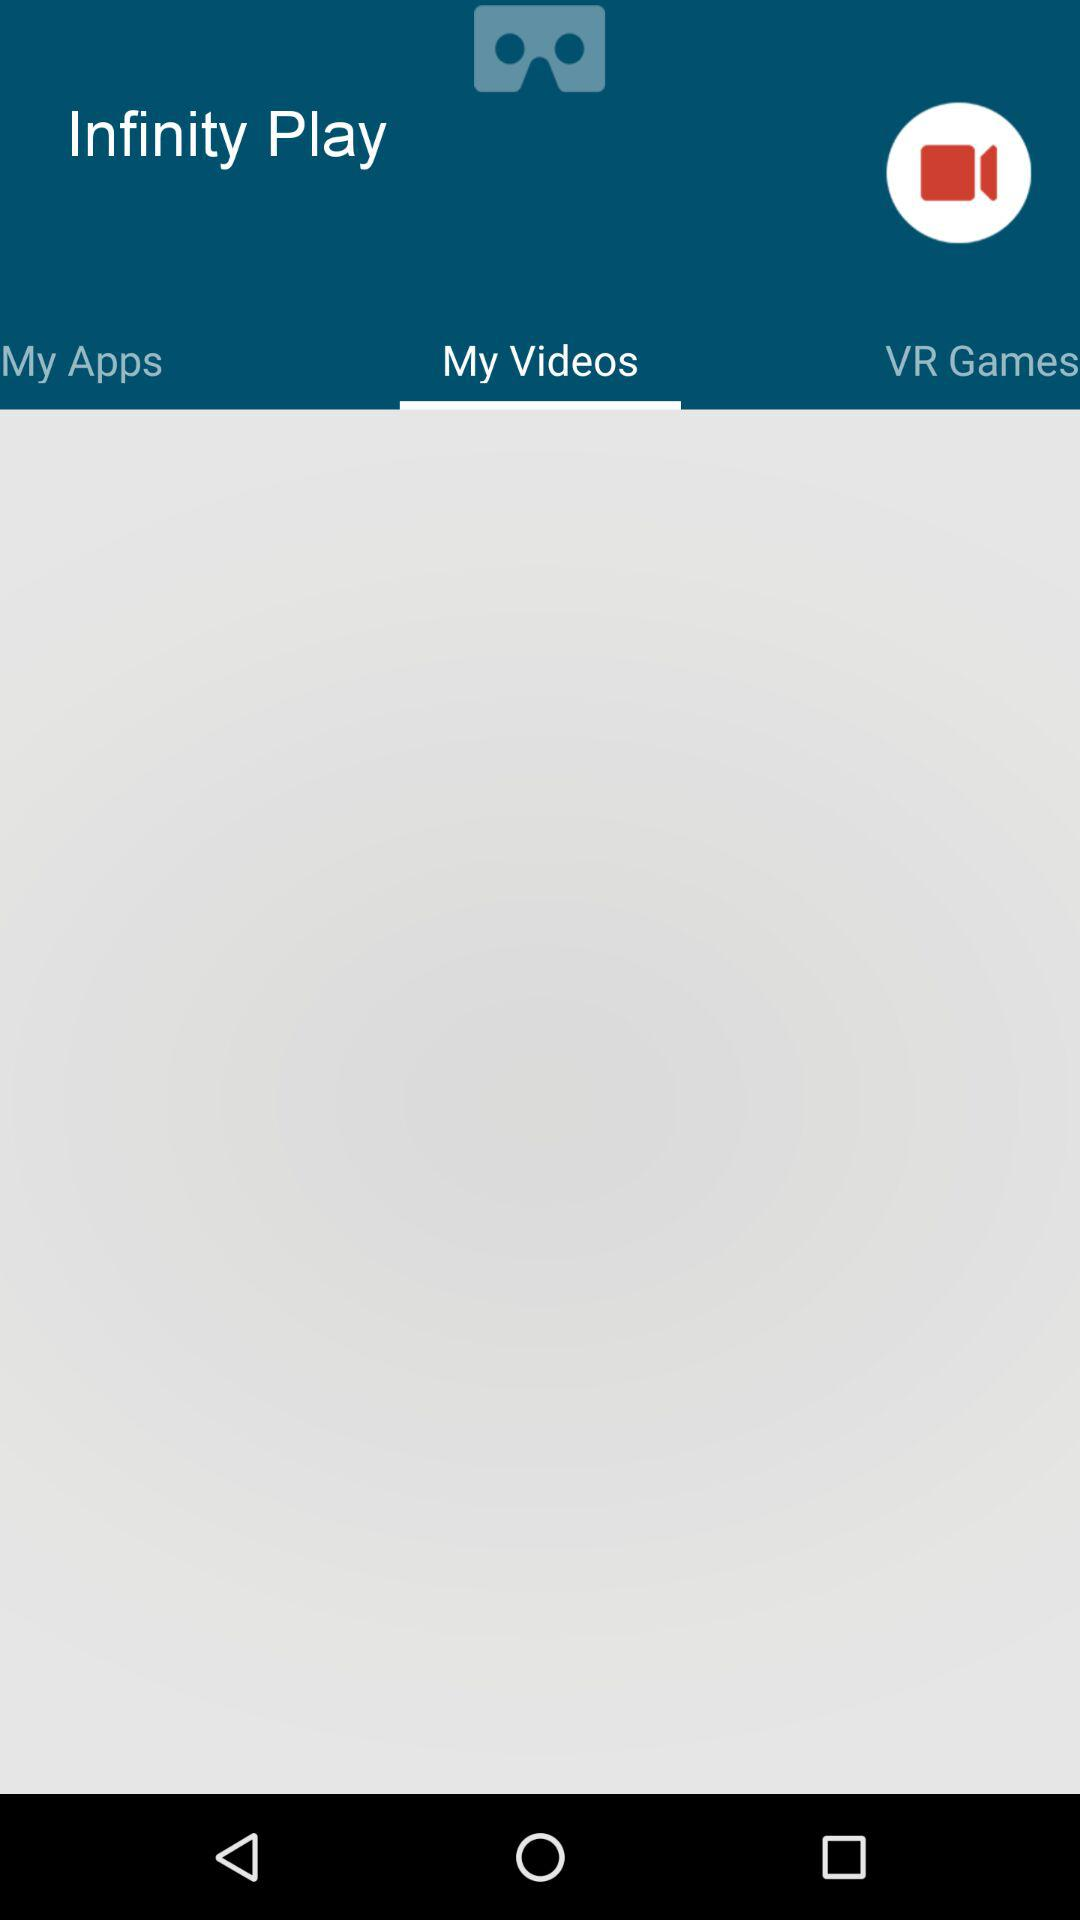Which tab is selected? The selected tab is "My Videos". 